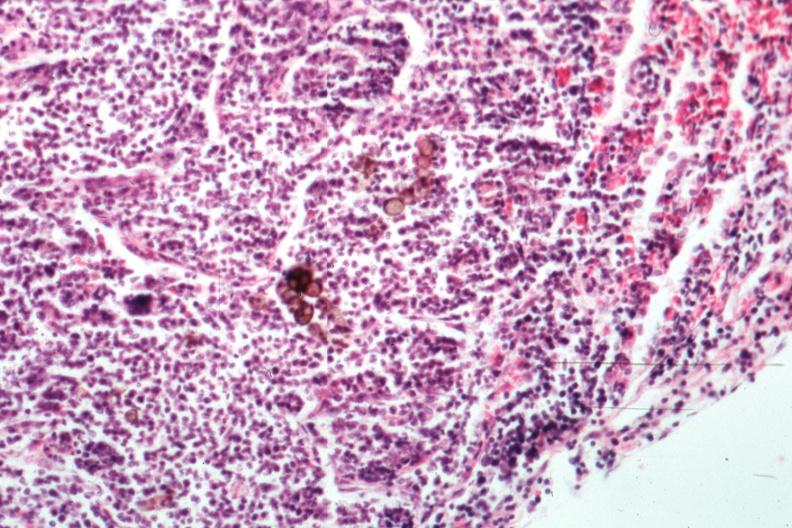where is this?
Answer the question using a single word or phrase. Skin 